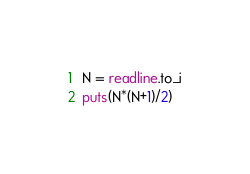<code> <loc_0><loc_0><loc_500><loc_500><_Ruby_>N = readline.to_i
puts(N*(N+1)/2)</code> 